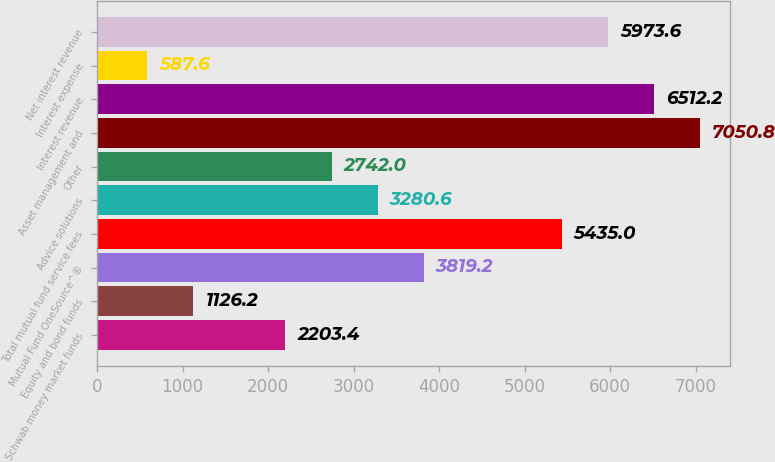Convert chart. <chart><loc_0><loc_0><loc_500><loc_500><bar_chart><fcel>Schwab money market funds<fcel>Equity and bond funds<fcel>Mutual Fund OneSource^®<fcel>Total mutual fund service fees<fcel>Advice solutions<fcel>Other<fcel>Asset management and<fcel>Interest revenue<fcel>Interest expense<fcel>Net interest revenue<nl><fcel>2203.4<fcel>1126.2<fcel>3819.2<fcel>5435<fcel>3280.6<fcel>2742<fcel>7050.8<fcel>6512.2<fcel>587.6<fcel>5973.6<nl></chart> 